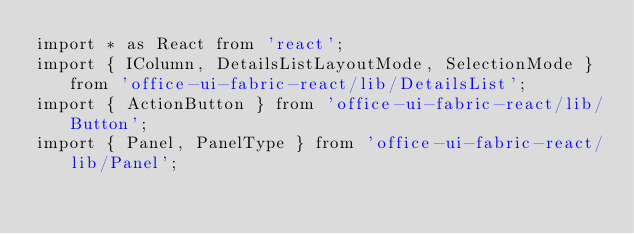<code> <loc_0><loc_0><loc_500><loc_500><_TypeScript_>import * as React from 'react';
import { IColumn, DetailsListLayoutMode, SelectionMode } from 'office-ui-fabric-react/lib/DetailsList';
import { ActionButton } from 'office-ui-fabric-react/lib/Button';
import { Panel, PanelType } from 'office-ui-fabric-react/lib/Panel';</code> 